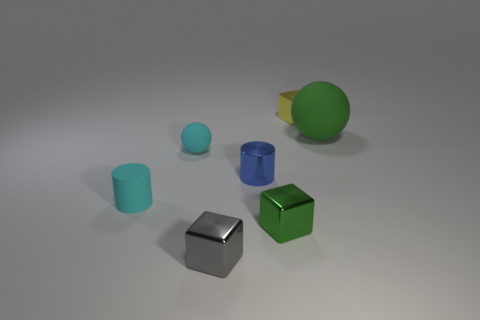Add 3 cyan matte balls. How many objects exist? 10 Subtract all spheres. How many objects are left? 5 Subtract 1 cyan balls. How many objects are left? 6 Subtract all matte cylinders. Subtract all metallic cubes. How many objects are left? 3 Add 4 yellow blocks. How many yellow blocks are left? 5 Add 5 large green matte balls. How many large green matte balls exist? 6 